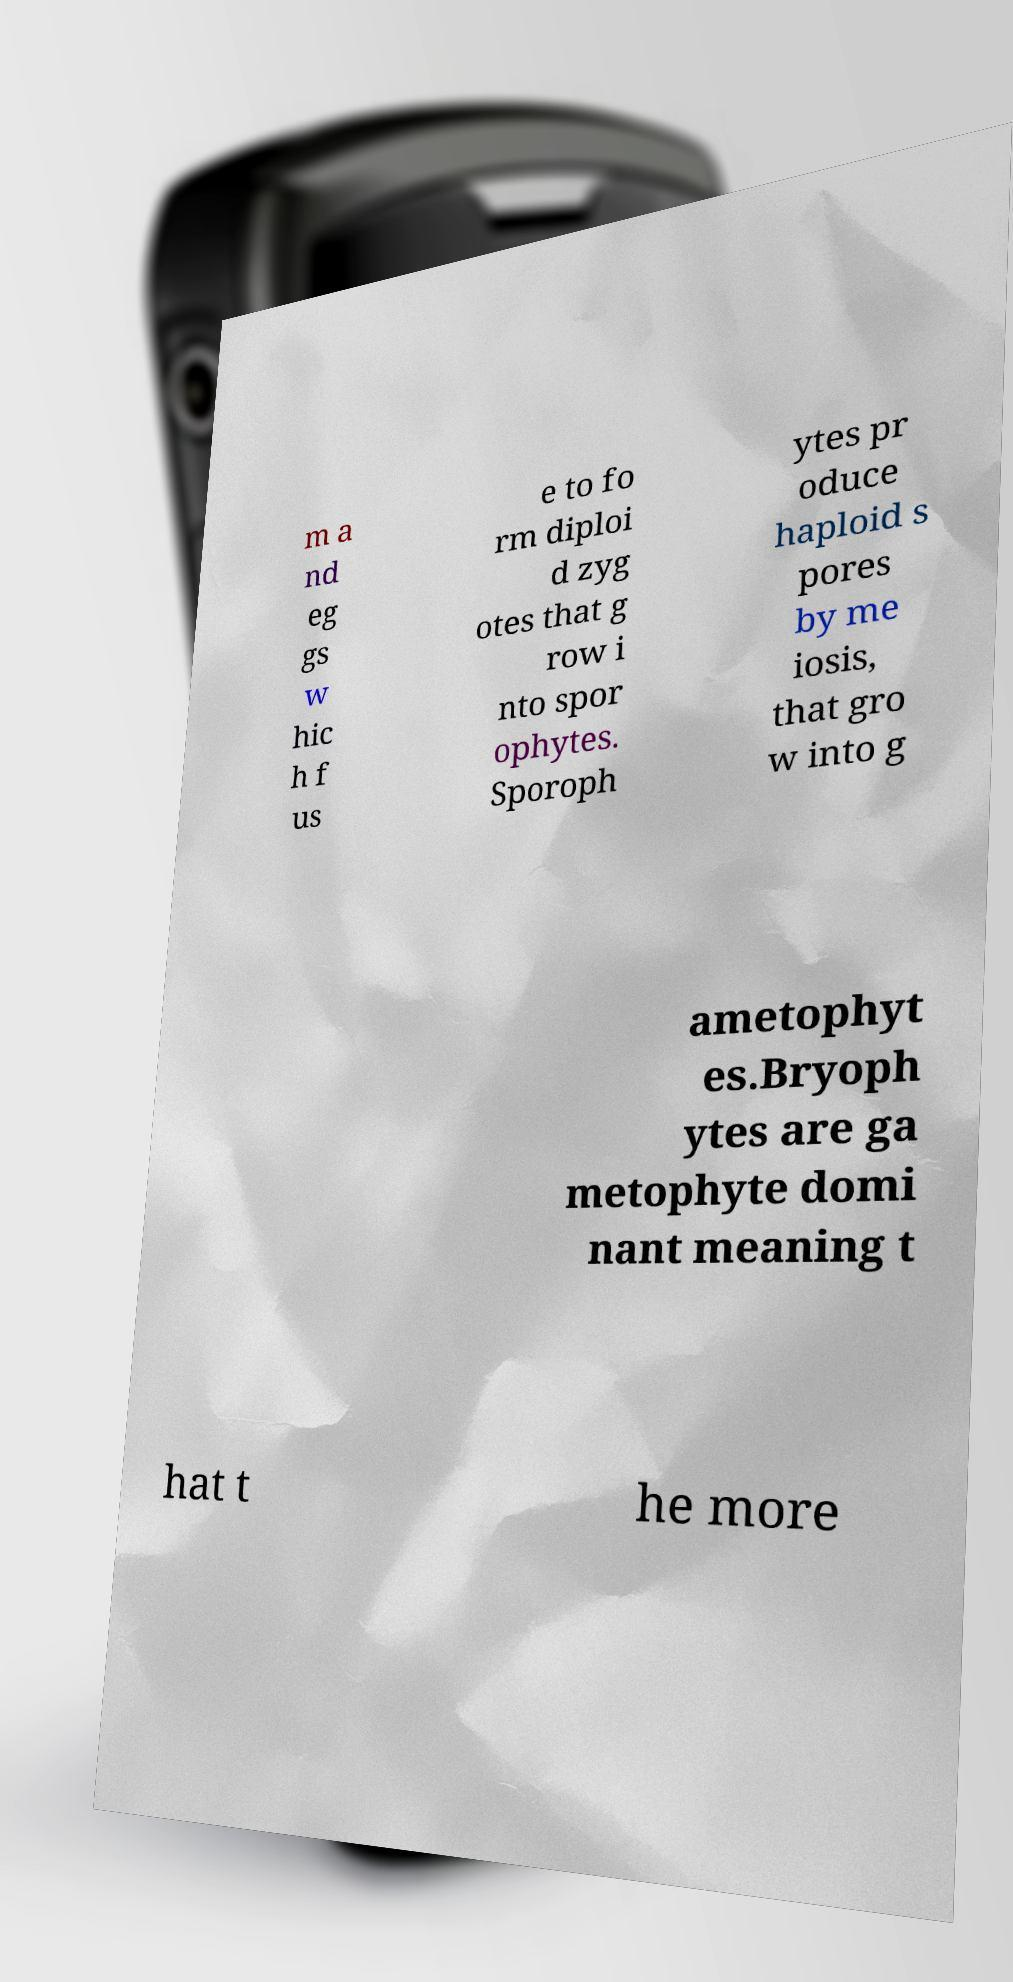Can you accurately transcribe the text from the provided image for me? m a nd eg gs w hic h f us e to fo rm diploi d zyg otes that g row i nto spor ophytes. Sporoph ytes pr oduce haploid s pores by me iosis, that gro w into g ametophyt es.Bryoph ytes are ga metophyte domi nant meaning t hat t he more 